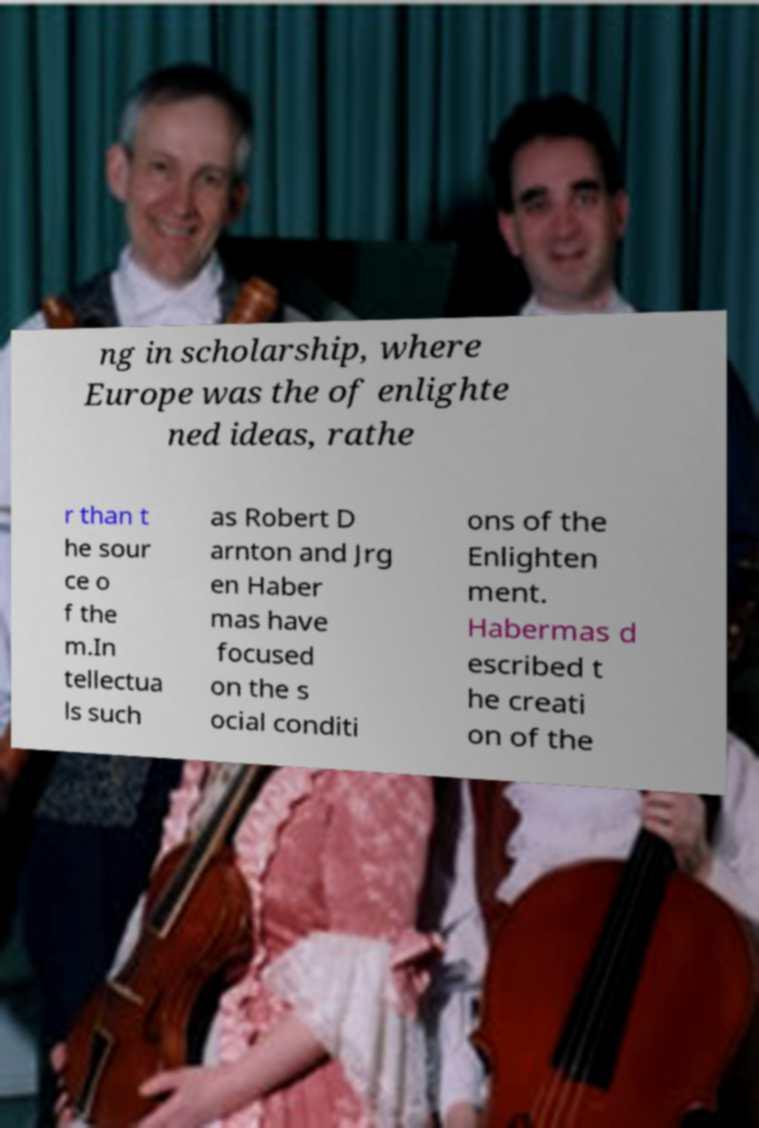Can you read and provide the text displayed in the image?This photo seems to have some interesting text. Can you extract and type it out for me? ng in scholarship, where Europe was the of enlighte ned ideas, rathe r than t he sour ce o f the m.In tellectua ls such as Robert D arnton and Jrg en Haber mas have focused on the s ocial conditi ons of the Enlighten ment. Habermas d escribed t he creati on of the 